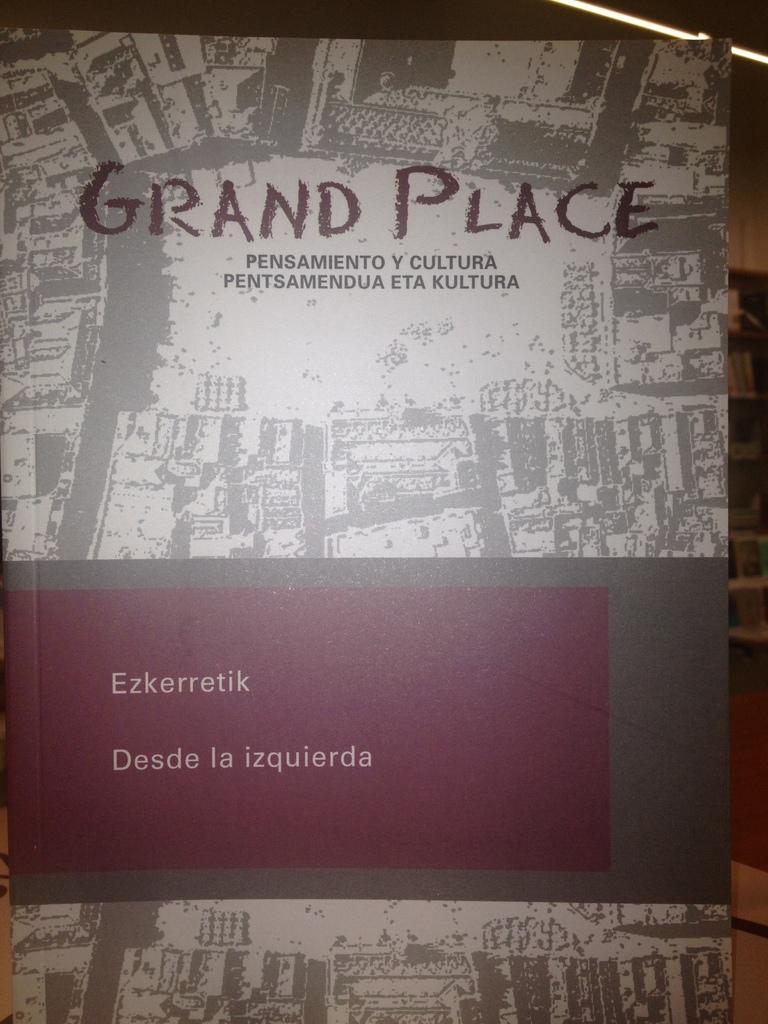What is the name of this book?
Offer a terse response. Grand place. 